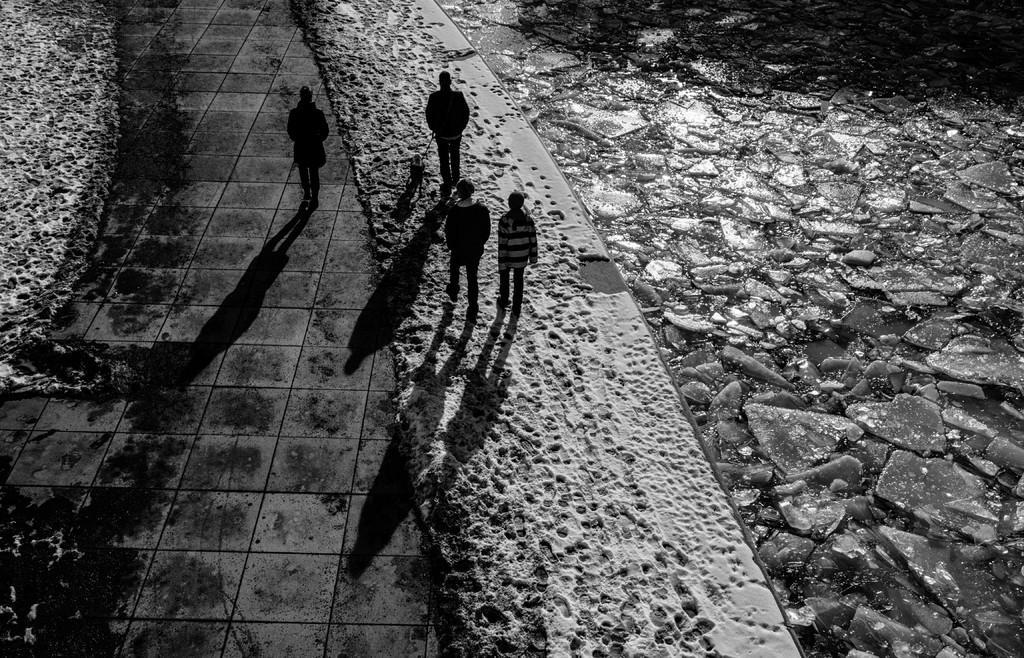In one or two sentences, can you explain what this image depicts? In this picture I can observe some people walking on the land. On the right side I can observe a stone path. This is a black and white image. 